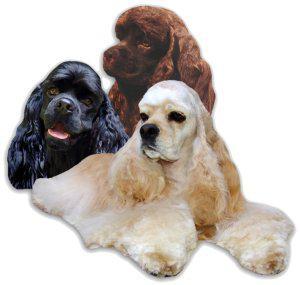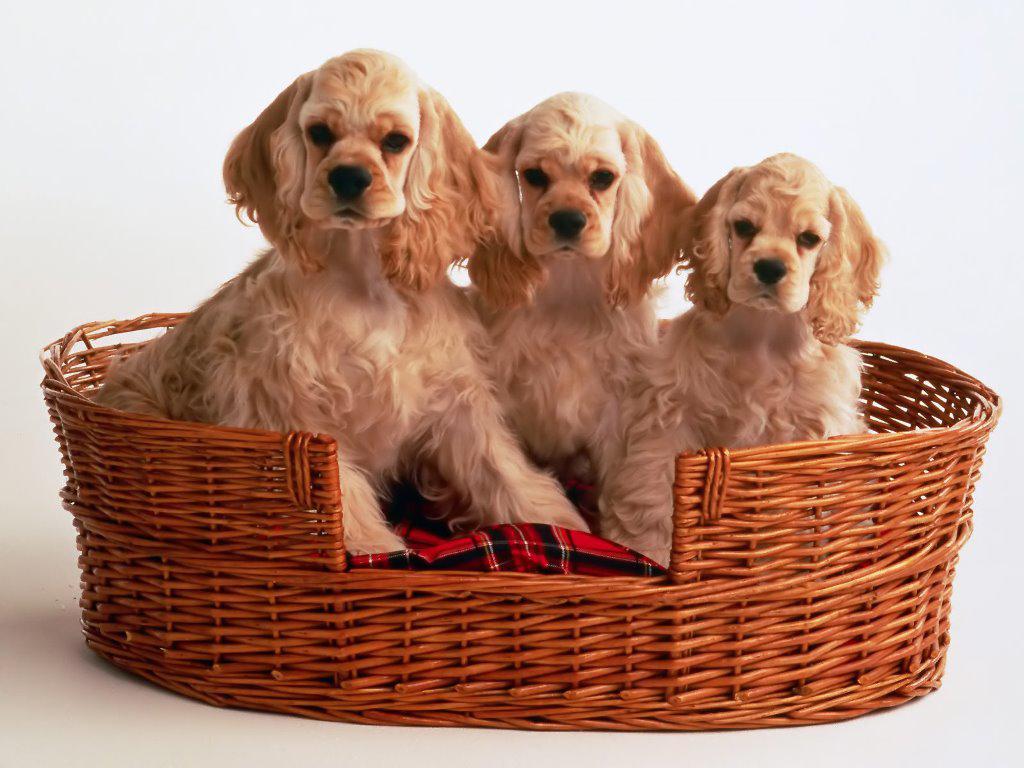The first image is the image on the left, the second image is the image on the right. Examine the images to the left and right. Is the description "There is exactly three dogs in the left image." accurate? Answer yes or no. Yes. The first image is the image on the left, the second image is the image on the right. Examine the images to the left and right. Is the description "Every image shoes exactly three dogs, where in one image all three dogs are blond colored and the other image they have varying colors." accurate? Answer yes or no. Yes. 